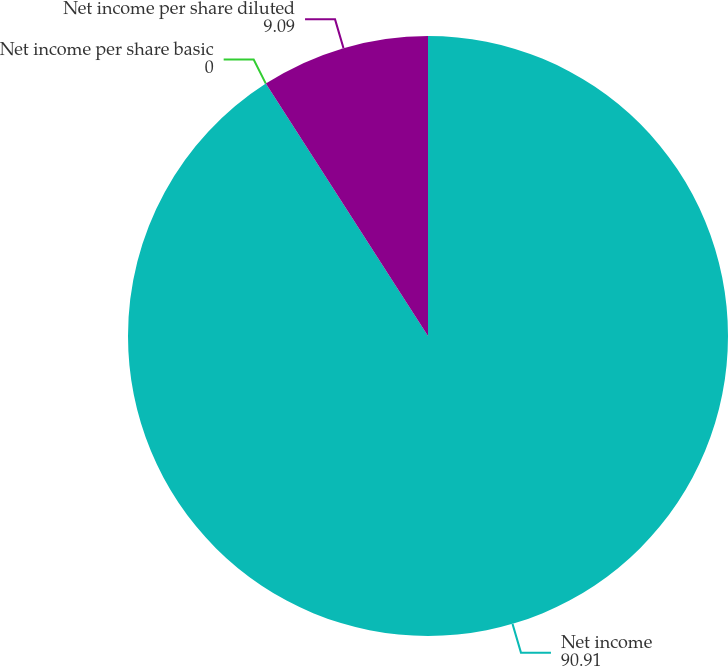<chart> <loc_0><loc_0><loc_500><loc_500><pie_chart><fcel>Net income<fcel>Net income per share basic<fcel>Net income per share diluted<nl><fcel>90.91%<fcel>0.0%<fcel>9.09%<nl></chart> 